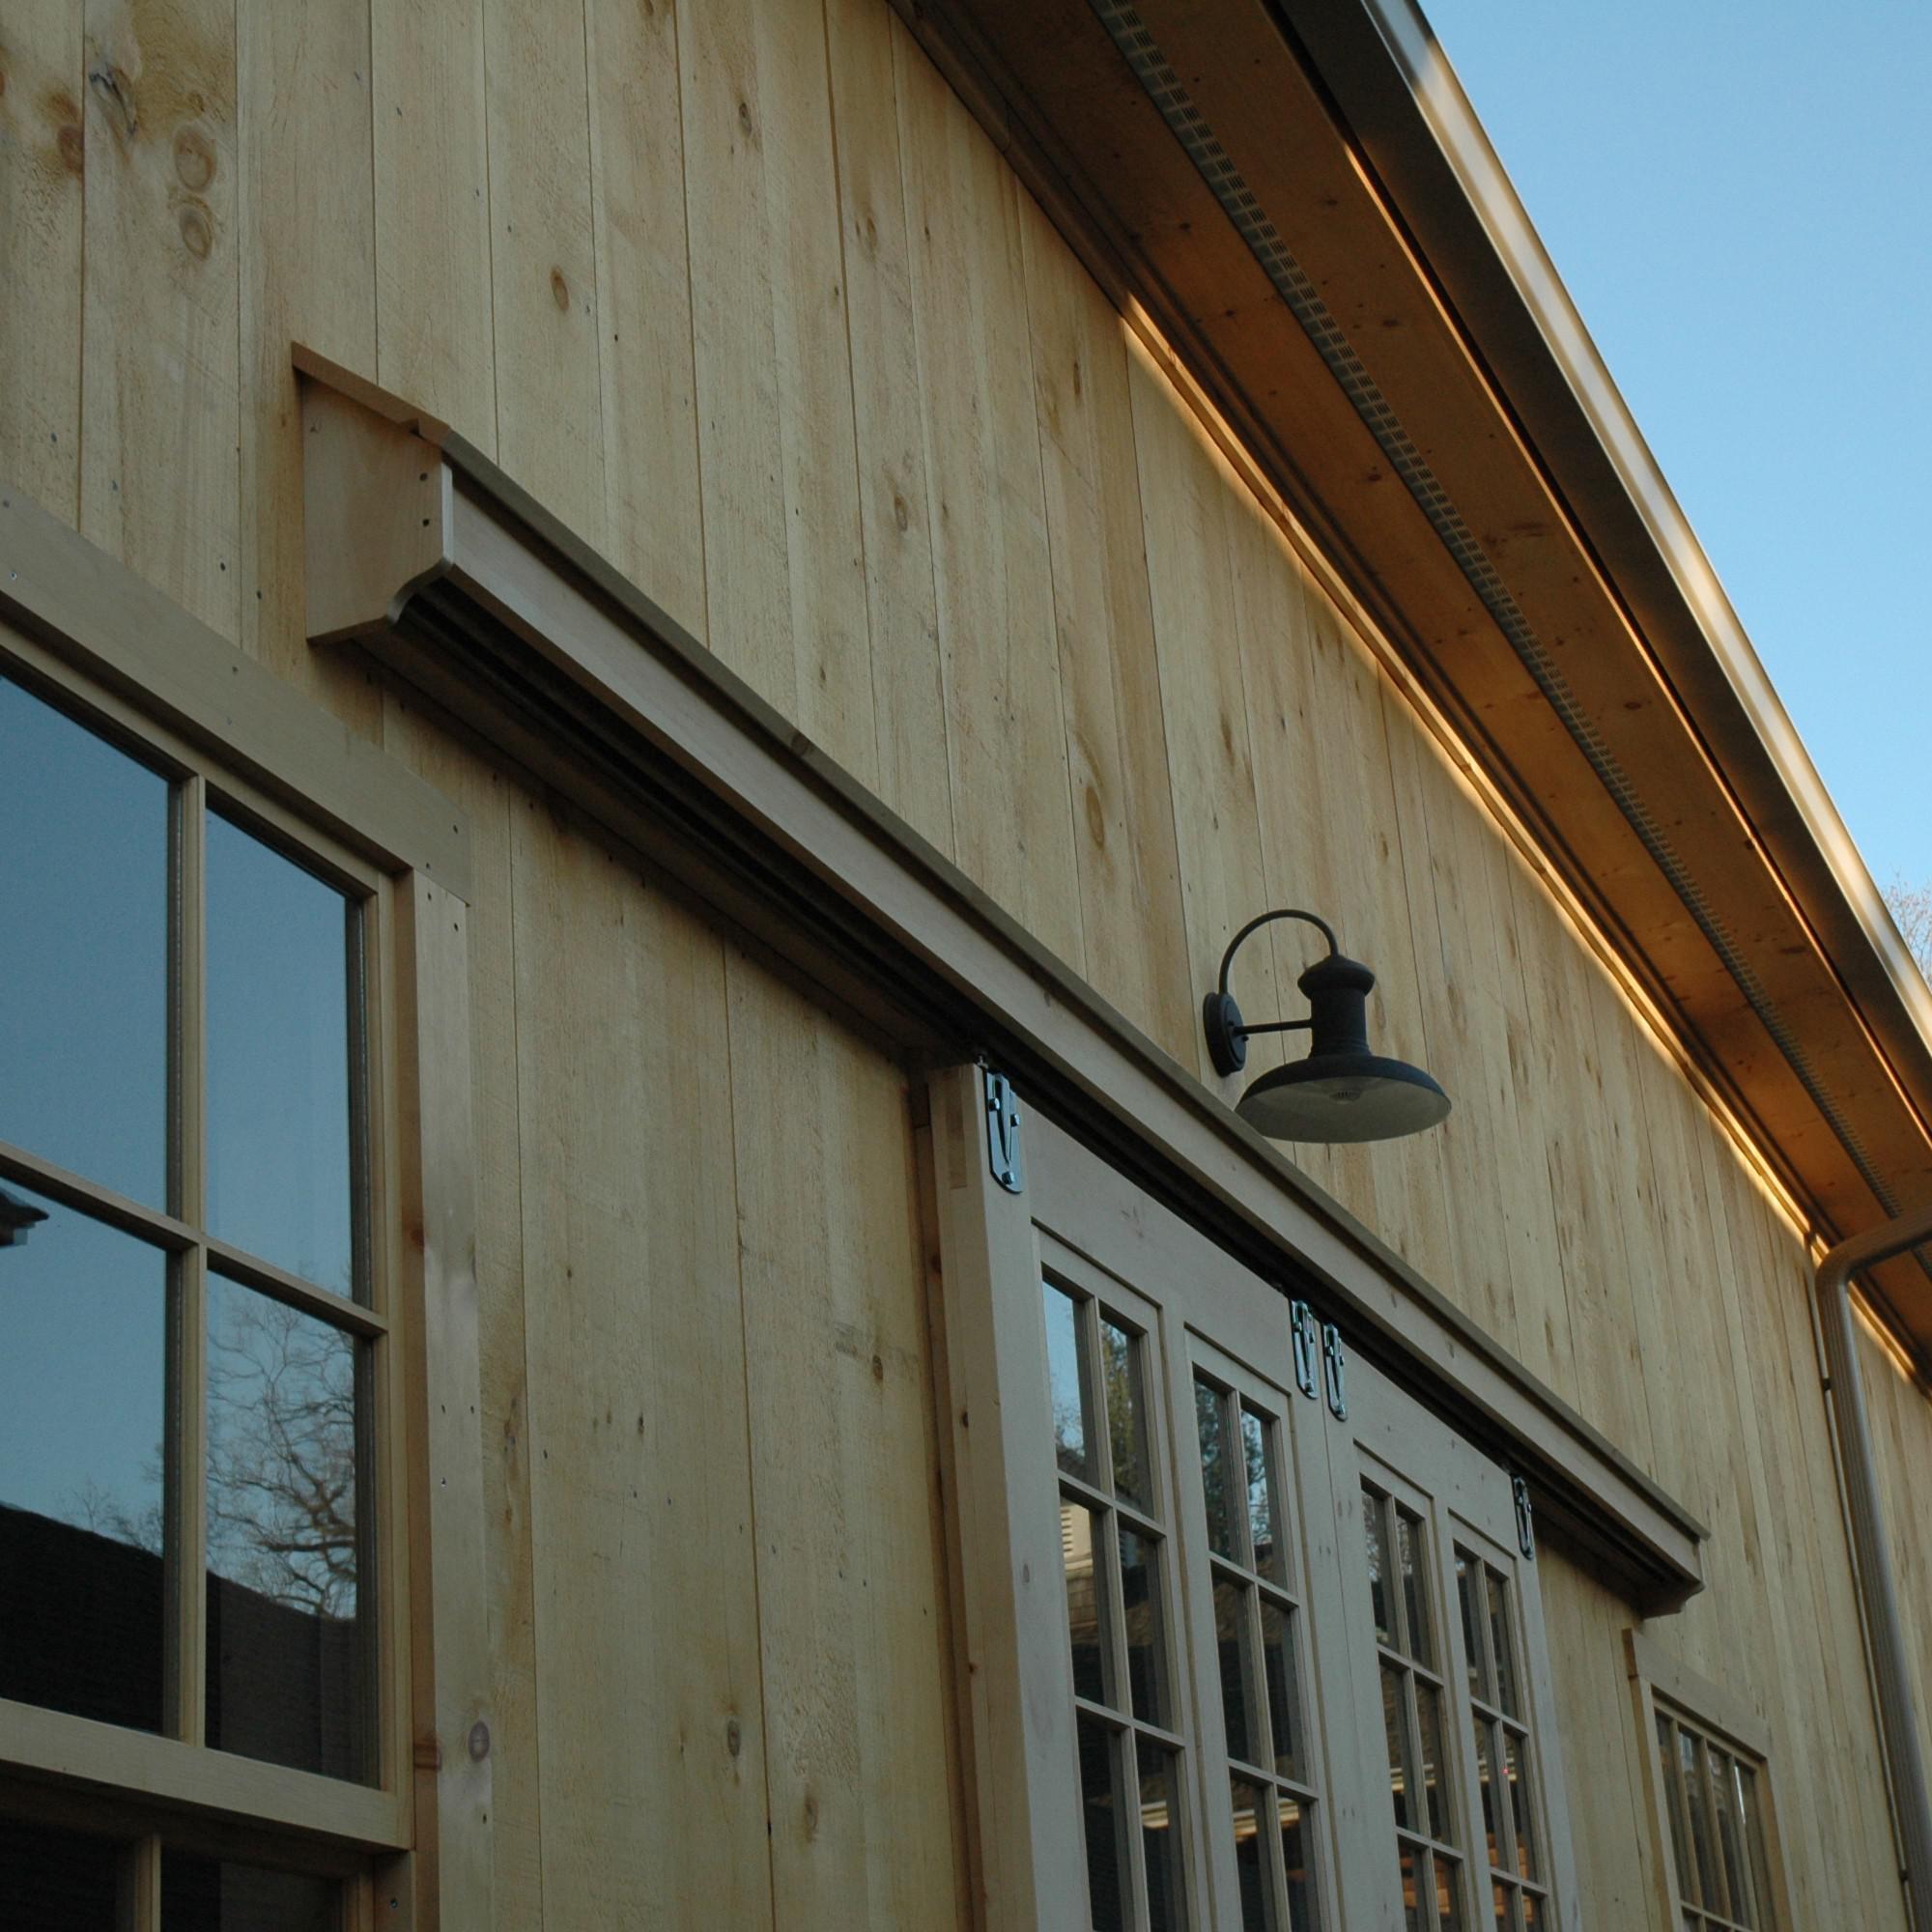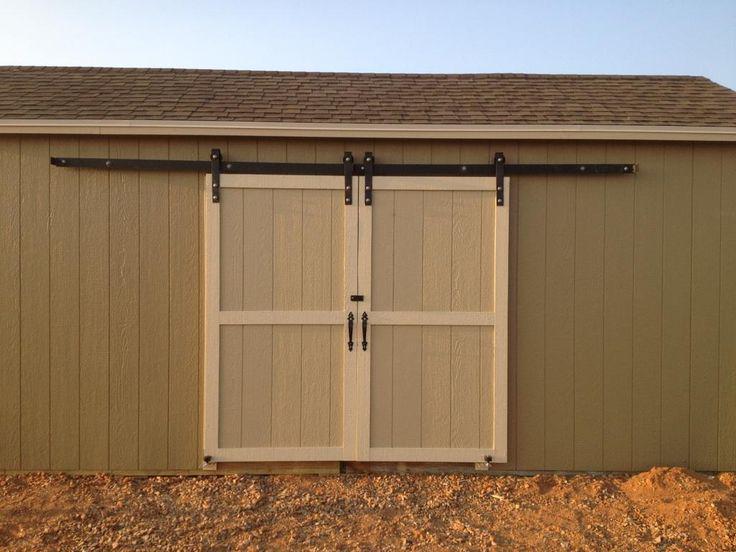The first image is the image on the left, the second image is the image on the right. Evaluate the accuracy of this statement regarding the images: "In one of the images the doors are open.". Is it true? Answer yes or no. No. 